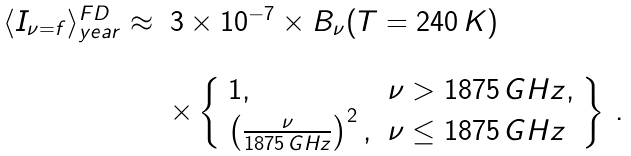<formula> <loc_0><loc_0><loc_500><loc_500>\begin{array} { l l } \langle I _ { \nu = f } \rangle _ { y e a r } ^ { F D } \approx & 3 \times 1 0 ^ { - 7 } \times B _ { \nu } ( T = 2 4 0 \, K ) \\ & \\ & \times \left \{ \begin{array} { l l } 1 , & \nu > 1 8 7 5 \, G H z , \\ \left ( \frac { \nu } { 1 8 7 5 \, G H z } \right ) ^ { 2 } , & \nu \leq 1 8 7 5 \, G H z \\ \end{array} \right \} \, . \end{array}</formula> 